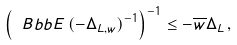Convert formula to latex. <formula><loc_0><loc_0><loc_500><loc_500>\left ( { \ B b b E } \, ( - \Delta _ { L , w } ) ^ { - 1 } \right ) ^ { - 1 } \leq - \overline { w } \Delta _ { L } \, ,</formula> 